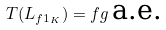<formula> <loc_0><loc_0><loc_500><loc_500>T ( L _ { f 1 _ { K } } ) = f g \, \text {a.e.}</formula> 